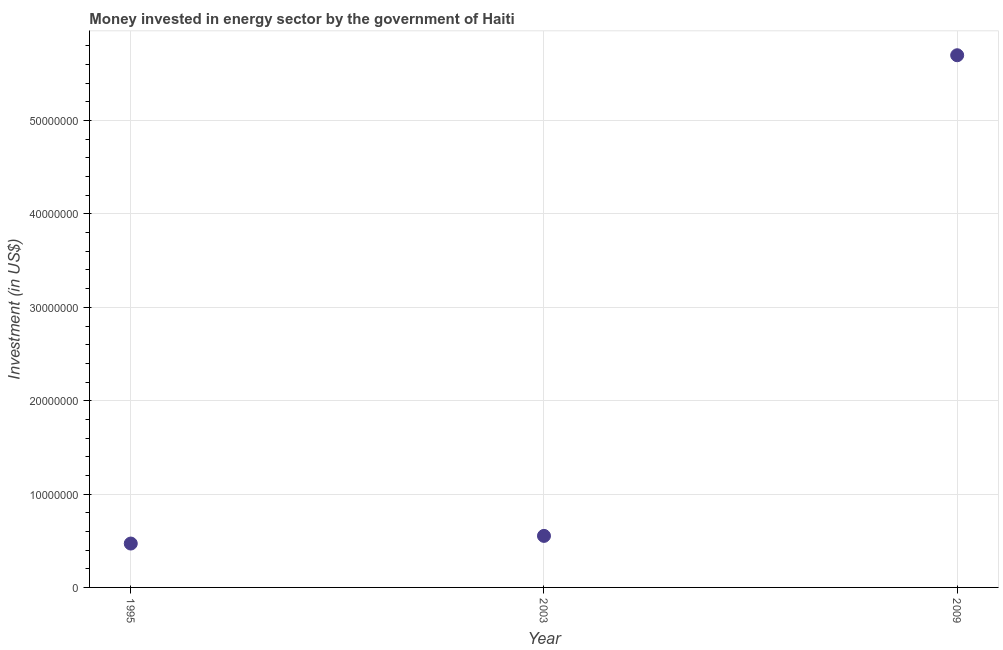What is the investment in energy in 1995?
Provide a short and direct response. 4.70e+06. Across all years, what is the maximum investment in energy?
Keep it short and to the point. 5.70e+07. Across all years, what is the minimum investment in energy?
Ensure brevity in your answer.  4.70e+06. In which year was the investment in energy maximum?
Provide a short and direct response. 2009. What is the sum of the investment in energy?
Your answer should be compact. 6.72e+07. What is the difference between the investment in energy in 2003 and 2009?
Offer a terse response. -5.15e+07. What is the average investment in energy per year?
Offer a very short reply. 2.24e+07. What is the median investment in energy?
Give a very brief answer. 5.52e+06. What is the ratio of the investment in energy in 1995 to that in 2003?
Your answer should be very brief. 0.85. Is the investment in energy in 1995 less than that in 2009?
Your answer should be compact. Yes. What is the difference between the highest and the second highest investment in energy?
Your answer should be compact. 5.15e+07. Is the sum of the investment in energy in 1995 and 2003 greater than the maximum investment in energy across all years?
Offer a very short reply. No. What is the difference between the highest and the lowest investment in energy?
Give a very brief answer. 5.23e+07. Does the investment in energy monotonically increase over the years?
Give a very brief answer. Yes. How many dotlines are there?
Provide a succinct answer. 1. How many years are there in the graph?
Your answer should be compact. 3. Are the values on the major ticks of Y-axis written in scientific E-notation?
Keep it short and to the point. No. Does the graph contain any zero values?
Offer a very short reply. No. Does the graph contain grids?
Keep it short and to the point. Yes. What is the title of the graph?
Ensure brevity in your answer.  Money invested in energy sector by the government of Haiti. What is the label or title of the Y-axis?
Ensure brevity in your answer.  Investment (in US$). What is the Investment (in US$) in 1995?
Your answer should be very brief. 4.70e+06. What is the Investment (in US$) in 2003?
Offer a terse response. 5.52e+06. What is the Investment (in US$) in 2009?
Make the answer very short. 5.70e+07. What is the difference between the Investment (in US$) in 1995 and 2003?
Your answer should be very brief. -8.20e+05. What is the difference between the Investment (in US$) in 1995 and 2009?
Offer a very short reply. -5.23e+07. What is the difference between the Investment (in US$) in 2003 and 2009?
Offer a terse response. -5.15e+07. What is the ratio of the Investment (in US$) in 1995 to that in 2003?
Provide a short and direct response. 0.85. What is the ratio of the Investment (in US$) in 1995 to that in 2009?
Offer a very short reply. 0.08. What is the ratio of the Investment (in US$) in 2003 to that in 2009?
Keep it short and to the point. 0.1. 